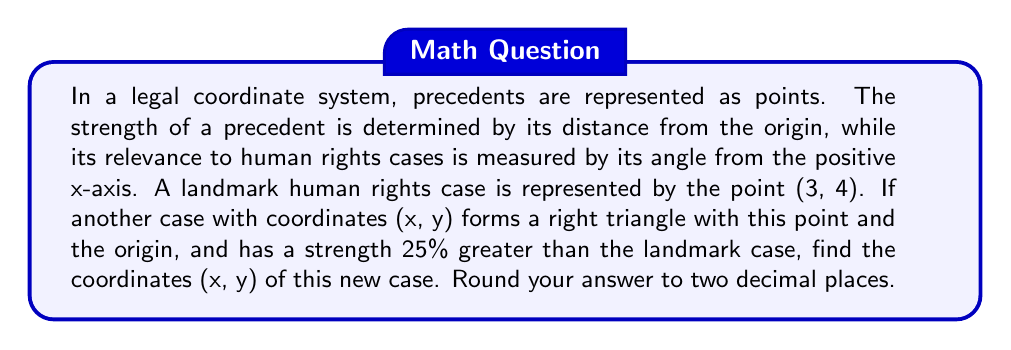Provide a solution to this math problem. Let's approach this step-by-step:

1) First, let's recall the distance formula in a coordinate plane:
   $$d = \sqrt{x^2 + y^2}$$

2) For the landmark case (3, 4), its strength (distance from origin) is:
   $$d_1 = \sqrt{3^2 + 4^2} = \sqrt{9 + 16} = \sqrt{25} = 5$$

3) The new case has a strength 25% greater, so its distance from the origin is:
   $$d_2 = 5 * 1.25 = 6.25$$

4) We're told that the new case forms a right triangle with the landmark case and the origin. This means we can use the Pythagorean theorem:
   $$(x - 3)^2 + (y - 4)^2 = 3^2 + 4^2 = 25$$

5) We also know that the distance of the new case from the origin is 6.25, so:
   $$x^2 + y^2 = 6.25^2 = 39.0625$$

6) Now we have a system of two equations:
   $$(x - 3)^2 + (y - 4)^2 = 25$$
   $$x^2 + y^2 = 39.0625$$

7) Expanding the first equation:
   $$x^2 - 6x + 9 + y^2 - 8y + 16 = 25$$
   $$x^2 + y^2 - 6x - 8y = 0$$

8) Subtracting the second equation from this:
   $$-6x - 8y = -39.0625$$

9) Dividing by 2:
   $$-3x - 4y = -19.53125$$

10) This is our line equation. Combining with $x^2 + y^2 = 39.0625$, we can solve for x and y.

11) From the line equation:
    $$y = -\frac{3x}{4} + 4.8828125$$

12) Substituting into $x^2 + y^2 = 39.0625$:
    $$x^2 + (-\frac{3x}{4} + 4.8828125)^2 = 39.0625$$

13) Solving this equation (which can be done with a calculator or computer algebra system) gives us:
    $$x \approx 5.77$$
    $$y \approx 2.56$$
Answer: (5.77, 2.56) 